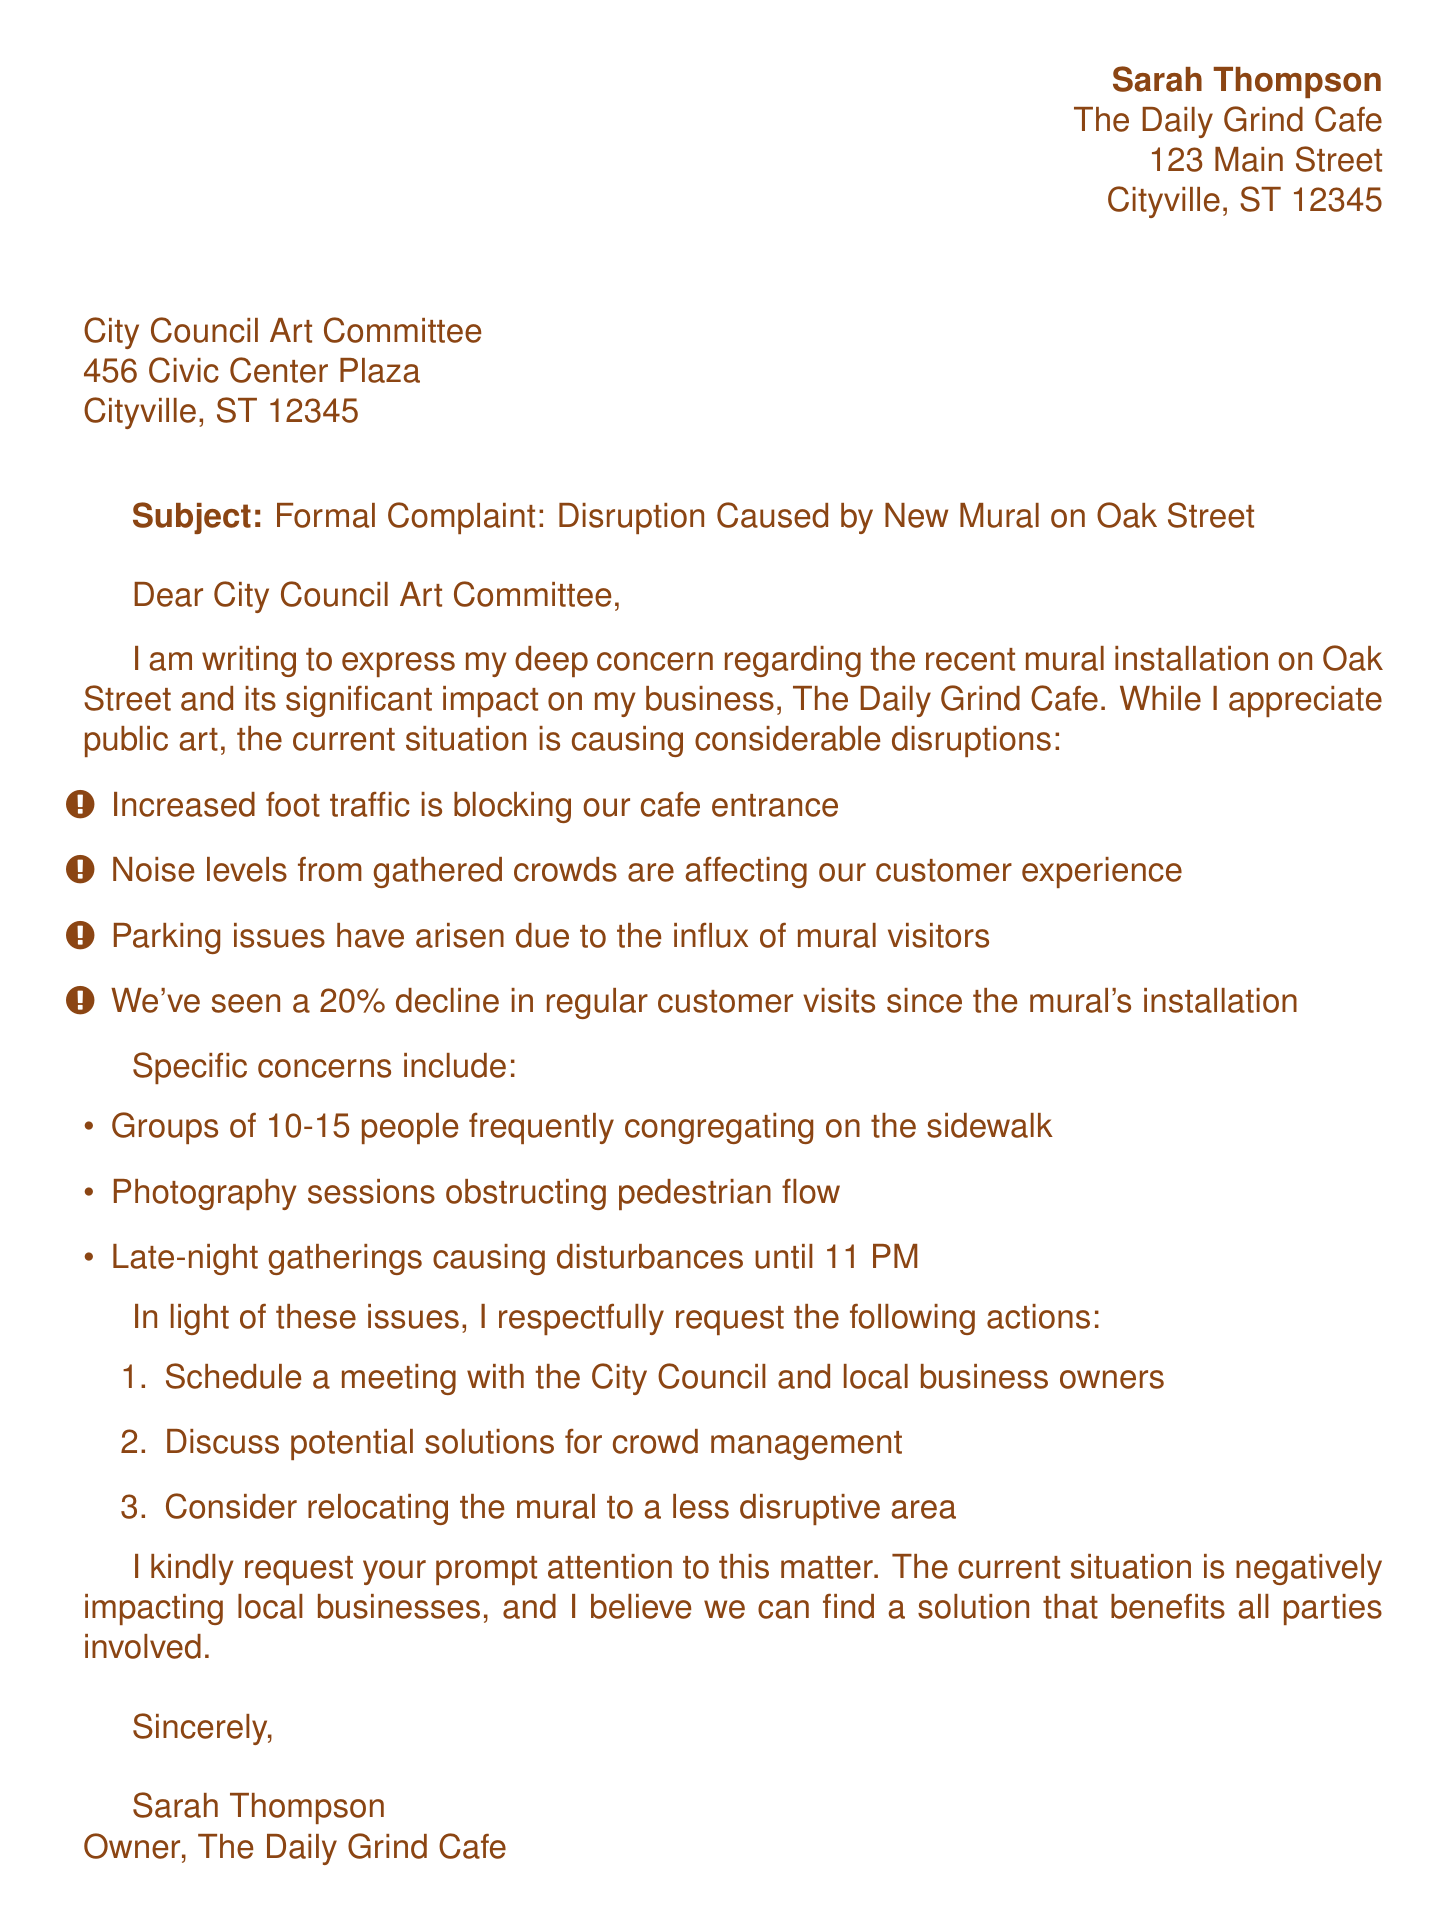what is the name of the sender? The sender's name is mentioned at the beginning of the document.
Answer: Sarah Thompson what is the address of the Daily Grind Cafe? The document provides the full address of the sender's business.
Answer: 123 Main Street, Cityville, ST 12345 how much has customer visits declined since the mural's installation? The document states a percentage reflecting the decline in customer visits.
Answer: 20% what specific issue is caused by late-night gatherings? The document mentions a particular concern regarding the timing of these gatherings.
Answer: Disturbances until 11 PM what does the sender request in terms of community engagement? The main points of the request emphasize a collaborative approach with local businesses and officials.
Answer: Schedule a meeting what is the primary concern of the sender regarding foot traffic? The document highlights a specific issue related to increased foot traffic affecting the business.
Answer: Blocking cafe entrance what kind of photography is causing disruption? The document points out a specific activity contributing to the pedestrian flow issue.
Answer: Photography sessions what is the closing statement about public art? The sender expresses a sentiment regarding public art despite the issues faced.
Answer: While I appreciate public art, the current situation is negatively impacting local businesses 